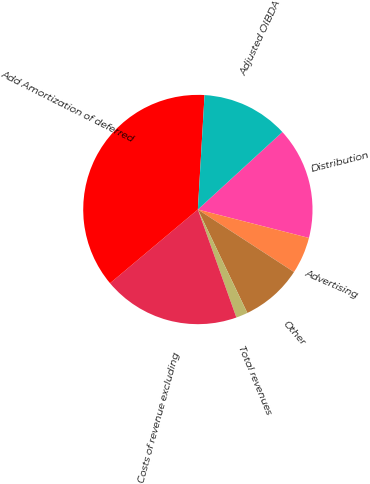Convert chart to OTSL. <chart><loc_0><loc_0><loc_500><loc_500><pie_chart><fcel>Distribution<fcel>Advertising<fcel>Other<fcel>Total revenues<fcel>Costs of revenue excluding<fcel>Add Amortization of deferred<fcel>Adjusted OIBDA<nl><fcel>15.8%<fcel>5.19%<fcel>8.72%<fcel>1.65%<fcel>19.34%<fcel>37.04%<fcel>12.26%<nl></chart> 